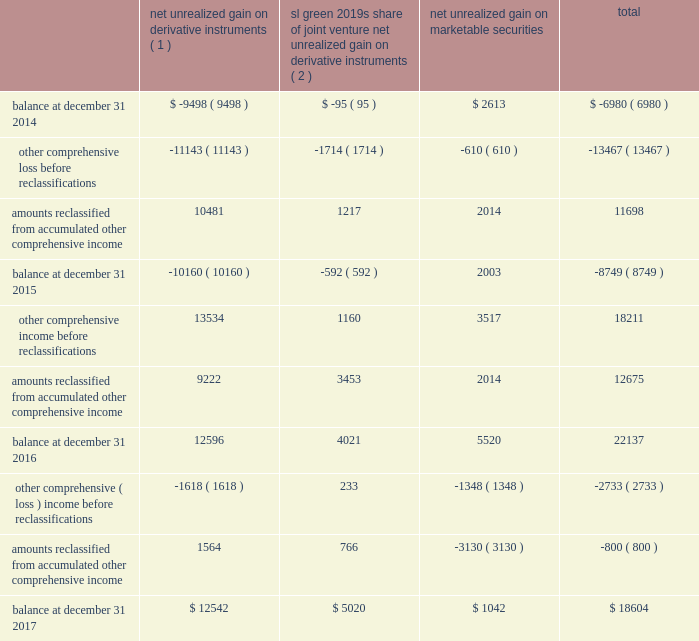108 / sl green realty corp .
2017 annual report espp provides for eligible employees to purchase the common stock at a purchase price equal to 85% ( 85 % ) of the lesser of ( 1 ) a0the market value of the common stock on the first day of the offer- ing period or ( 2 ) a0the market value of the common stock on the last day of the offering period .
The espp was approved by our stockholders at our 2008 annual meeting of stockholders .
As of december a031 , 2017 , 104597 a0shares of our common stock had been issued under the espp .
Available for issuance , subject to adjustment upon a merger , reorganization , stock split or other similar corporate change .
The company filed a registration statement on form a0s-8 with the sec with respect to the espp .
The common stock is offered for purchase through a series of successive offering periods .
Each offering period will be three months in duration and will begin on the first day of each calendar quarter , with the first a0offering period having commenced on january a01 , 2008 .
The 15 .
Accumulated other comprehensive income the tables set forth the changes in accumulated other comprehensive income ( loss ) by component as of december a031 , 2017 , 2016 and 2015 ( in thousands ) : sl a0green 2019s share net unrealized of joint venture net unrealized gain on net unrealized gain on derivative gain on derivative marketable instruments ( 1 ) instruments ( 2 ) securities total .
( 1 ) amount reclassified from accumulated other comprehensive income ( loss ) is included in interest expense in the respective consolidated statements of operations .
As of december a031 , 2017 and 2016 , the deferred net losses from these terminated hedges , which is included in accumulated other comprehensive loss relating to net unrealized loss on derivative instrument , was $ 3.2 a0million and $ 7.1 a0million , respectively .
( 2 ) amount reclassified from accumulated other comprehensive income ( loss ) is included in equity in net income from unconsolidated joint ventures in the respective consolidated statements of operations .
16 .
Fair value measurements we are required to disclose fair value information with regard to our financial instruments , whether or not recognized in the consolidated balance sheets , for which it is practical to estimate fair value .
The fasb guidance defines fair value as the price that would be received to sell an asset or paid to transfer a liability in an orderly transaction between market participants on the measurement date .
We measure and/or disclose the estimated fair value of financial assets and liabilities based on a hierarchy that distinguishes between market participant assumptions based on market data obtained from sources independent of the reporting entity and the reporting entity 2019s own assumptions about market participant assumptions .
This hierarchy consists of three broad levels : level a01 2014 quoted prices ( unadjusted ) in active markets for identical assets or liabilities that the reporting entity can access at the measurement date ; level a02 2014 inputs other than quoted prices included within level a01 , that are observable for the asset or liability , either directly or indirectly ; and level a03 2014 unobservable inputs for the asset or liability that are used when little or no market data is available .
We follow this hierarchy for our assets and liabilities measured at fair value on a recurring and nonrecurring basis .
In instances in which the determination of the fair value measurement is based on inputs from different levels of the fair value hierarchy , the level in the fair value hierarchy within which the entire fair value measure- ment falls is based on the lowest level of input that is significant to the fair value measurement in its entirety .
Our assessment of the significance of the particular input to the fair value mea- surement in its entirety requires judgment and considers factors specific to the asset or liability. .
Is the aoci balance for marketable securities greater than derivatives as of december 31 2017? 
Computations: (1042 > 12542)
Answer: no. 